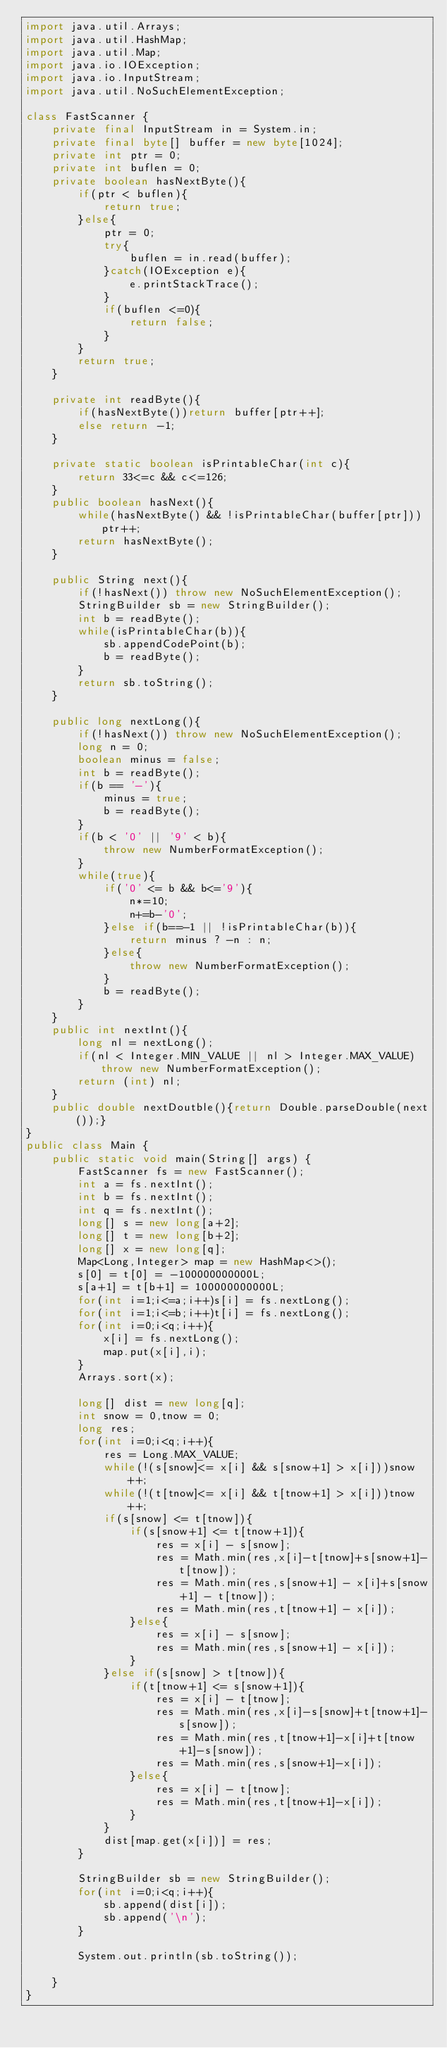<code> <loc_0><loc_0><loc_500><loc_500><_Java_>import java.util.Arrays;
import java.util.HashMap;
import java.util.Map;
import java.io.IOException;
import java.io.InputStream;
import java.util.NoSuchElementException;

class FastScanner {
    private final InputStream in = System.in;
    private final byte[] buffer = new byte[1024];
    private int ptr = 0;
    private int buflen = 0;
    private boolean hasNextByte(){
        if(ptr < buflen){
            return true;
        }else{
            ptr = 0;
            try{
                buflen = in.read(buffer);
            }catch(IOException e){
                e.printStackTrace();
            }
            if(buflen <=0){
                return false;
            }
        }
        return true;
    }

    private int readByte(){
        if(hasNextByte())return buffer[ptr++];
        else return -1;
    }

    private static boolean isPrintableChar(int c){
        return 33<=c && c<=126;
    }
    public boolean hasNext(){
        while(hasNextByte() && !isPrintableChar(buffer[ptr]))ptr++;
        return hasNextByte();
    }

    public String next(){
        if(!hasNext()) throw new NoSuchElementException();
        StringBuilder sb = new StringBuilder();
        int b = readByte();
        while(isPrintableChar(b)){
            sb.appendCodePoint(b);
            b = readByte();
        }
        return sb.toString();
    }

    public long nextLong(){
        if(!hasNext()) throw new NoSuchElementException();
        long n = 0;
        boolean minus = false;
        int b = readByte();
        if(b == '-'){
            minus = true;
            b = readByte();
        }
        if(b < '0' || '9' < b){
            throw new NumberFormatException();
        }
        while(true){
            if('0' <= b && b<='9'){
                n*=10;
                n+=b-'0';
            }else if(b==-1 || !isPrintableChar(b)){
                return minus ? -n : n;
            }else{
                throw new NumberFormatException();
            }
            b = readByte();
        }
    }
    public int nextInt(){
        long nl = nextLong();
        if(nl < Integer.MIN_VALUE || nl > Integer.MAX_VALUE)throw new NumberFormatException();
        return (int) nl;
    }
    public double nextDoutble(){return Double.parseDouble(next());}
}
public class Main {
    public static void main(String[] args) {
        FastScanner fs = new FastScanner();
        int a = fs.nextInt();
        int b = fs.nextInt();
        int q = fs.nextInt();
        long[] s = new long[a+2];
        long[] t = new long[b+2];
        long[] x = new long[q];
        Map<Long,Integer> map = new HashMap<>();
        s[0] = t[0] = -100000000000L;
        s[a+1] = t[b+1] = 100000000000L;
        for(int i=1;i<=a;i++)s[i] = fs.nextLong();
        for(int i=1;i<=b;i++)t[i] = fs.nextLong();
        for(int i=0;i<q;i++){
            x[i] = fs.nextLong();
            map.put(x[i],i);
        }
        Arrays.sort(x);

        long[] dist = new long[q];
        int snow = 0,tnow = 0;
        long res;
        for(int i=0;i<q;i++){
            res = Long.MAX_VALUE;
            while(!(s[snow]<= x[i] && s[snow+1] > x[i]))snow++;
            while(!(t[tnow]<= x[i] && t[tnow+1] > x[i]))tnow++;
            if(s[snow] <= t[tnow]){
                if(s[snow+1] <= t[tnow+1]){
                    res = x[i] - s[snow];
                    res = Math.min(res,x[i]-t[tnow]+s[snow+1]-t[tnow]);
                    res = Math.min(res,s[snow+1] - x[i]+s[snow+1] - t[tnow]);
                    res = Math.min(res,t[tnow+1] - x[i]);
                }else{
                    res = x[i] - s[snow];
                    res = Math.min(res,s[snow+1] - x[i]);
                }
            }else if(s[snow] > t[tnow]){
                if(t[tnow+1] <= s[snow+1]){
                    res = x[i] - t[tnow];
                    res = Math.min(res,x[i]-s[snow]+t[tnow+1]-s[snow]);
                    res = Math.min(res,t[tnow+1]-x[i]+t[tnow+1]-s[snow]);
                    res = Math.min(res,s[snow+1]-x[i]);
                }else{
                    res = x[i] - t[tnow];
                    res = Math.min(res,t[tnow+1]-x[i]);
                }
            }
            dist[map.get(x[i])] = res;
        }

        StringBuilder sb = new StringBuilder();
        for(int i=0;i<q;i++){
            sb.append(dist[i]);
            sb.append('\n');
        }

        System.out.println(sb.toString());

    }
}</code> 